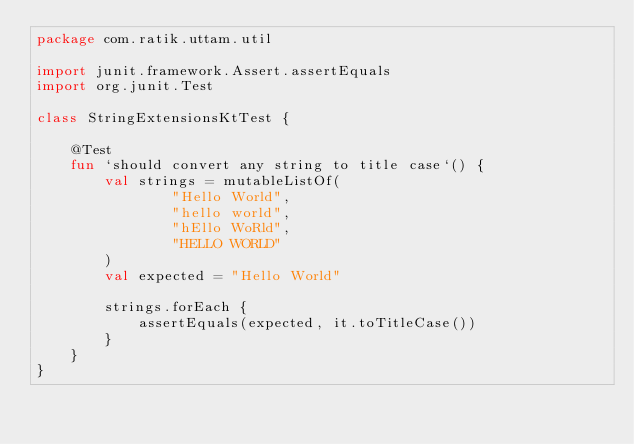Convert code to text. <code><loc_0><loc_0><loc_500><loc_500><_Kotlin_>package com.ratik.uttam.util

import junit.framework.Assert.assertEquals
import org.junit.Test

class StringExtensionsKtTest {

    @Test
    fun `should convert any string to title case`() {
        val strings = mutableListOf(
                "Hello World",
                "hello world",
                "hEllo WoRld",
                "HELLO WORLD"
        )
        val expected = "Hello World"

        strings.forEach {
            assertEquals(expected, it.toTitleCase())
        }
    }
}</code> 